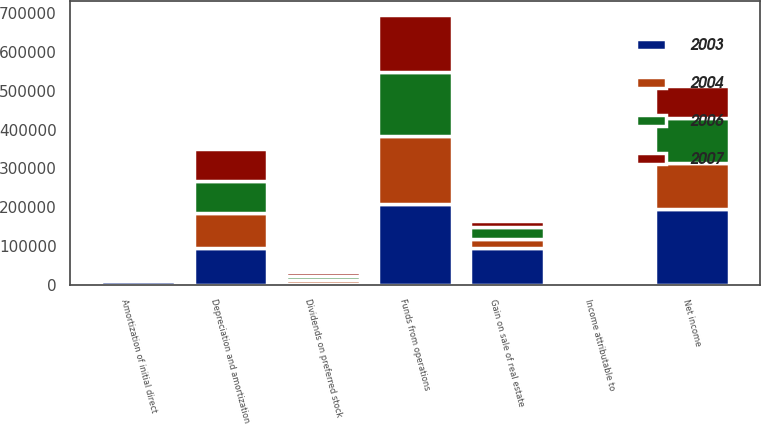Convert chart. <chart><loc_0><loc_0><loc_500><loc_500><stacked_bar_chart><ecel><fcel>Net income<fcel>Gain on sale of real estate<fcel>Depreciation and amortization<fcel>Amortization of initial direct<fcel>Funds from operations<fcel>Dividends on preferred stock<fcel>Income attributable to<nl><fcel>2003<fcel>195537<fcel>94768<fcel>95565<fcel>8473<fcel>206762<fcel>442<fcel>1156<nl><fcel>2004<fcel>118712<fcel>23956<fcel>88649<fcel>7390<fcel>177113<fcel>10423<fcel>748<nl><fcel>2006<fcel>114612<fcel>30748<fcel>82752<fcel>6972<fcel>163544<fcel>11475<fcel>801<nl><fcel>2007<fcel>84156<fcel>14052<fcel>81649<fcel>7151<fcel>148671<fcel>11475<fcel>1055<nl></chart> 